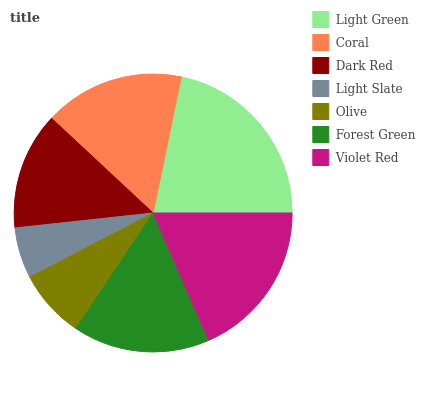Is Light Slate the minimum?
Answer yes or no. Yes. Is Light Green the maximum?
Answer yes or no. Yes. Is Coral the minimum?
Answer yes or no. No. Is Coral the maximum?
Answer yes or no. No. Is Light Green greater than Coral?
Answer yes or no. Yes. Is Coral less than Light Green?
Answer yes or no. Yes. Is Coral greater than Light Green?
Answer yes or no. No. Is Light Green less than Coral?
Answer yes or no. No. Is Forest Green the high median?
Answer yes or no. Yes. Is Forest Green the low median?
Answer yes or no. Yes. Is Light Green the high median?
Answer yes or no. No. Is Coral the low median?
Answer yes or no. No. 